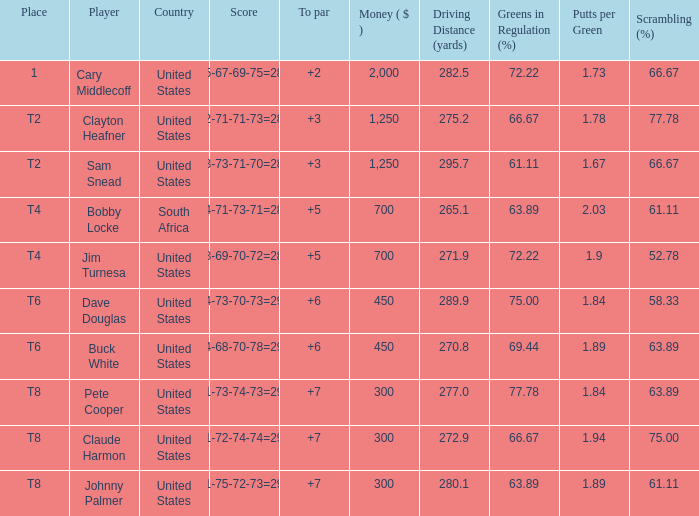What is Claude Harmon's Place? T8. 